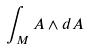Convert formula to latex. <formula><loc_0><loc_0><loc_500><loc_500>\int _ { M } A \wedge d A</formula> 